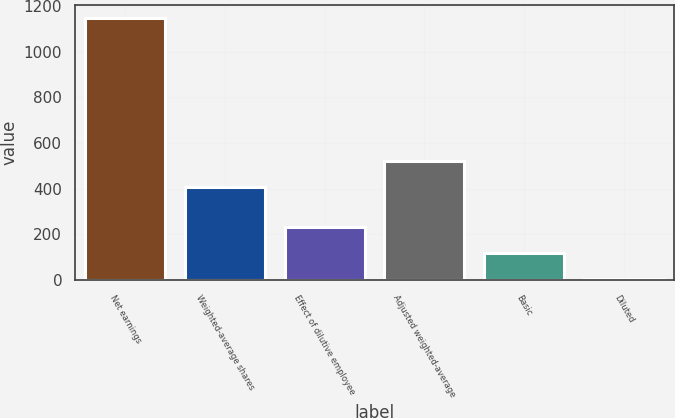Convert chart to OTSL. <chart><loc_0><loc_0><loc_500><loc_500><bar_chart><fcel>Net earnings<fcel>Weighted-average shares<fcel>Effect of dilutive employee<fcel>Adjusted weighted-average<fcel>Basic<fcel>Diluted<nl><fcel>1147.8<fcel>408.1<fcel>231.78<fcel>522.6<fcel>117.28<fcel>2.78<nl></chart> 